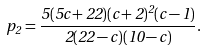<formula> <loc_0><loc_0><loc_500><loc_500>p _ { 2 } = \frac { 5 ( 5 c + 2 2 ) ( c + 2 ) ^ { 2 } ( c - 1 ) } { 2 ( 2 2 - c ) ( 1 0 - c ) } .</formula> 